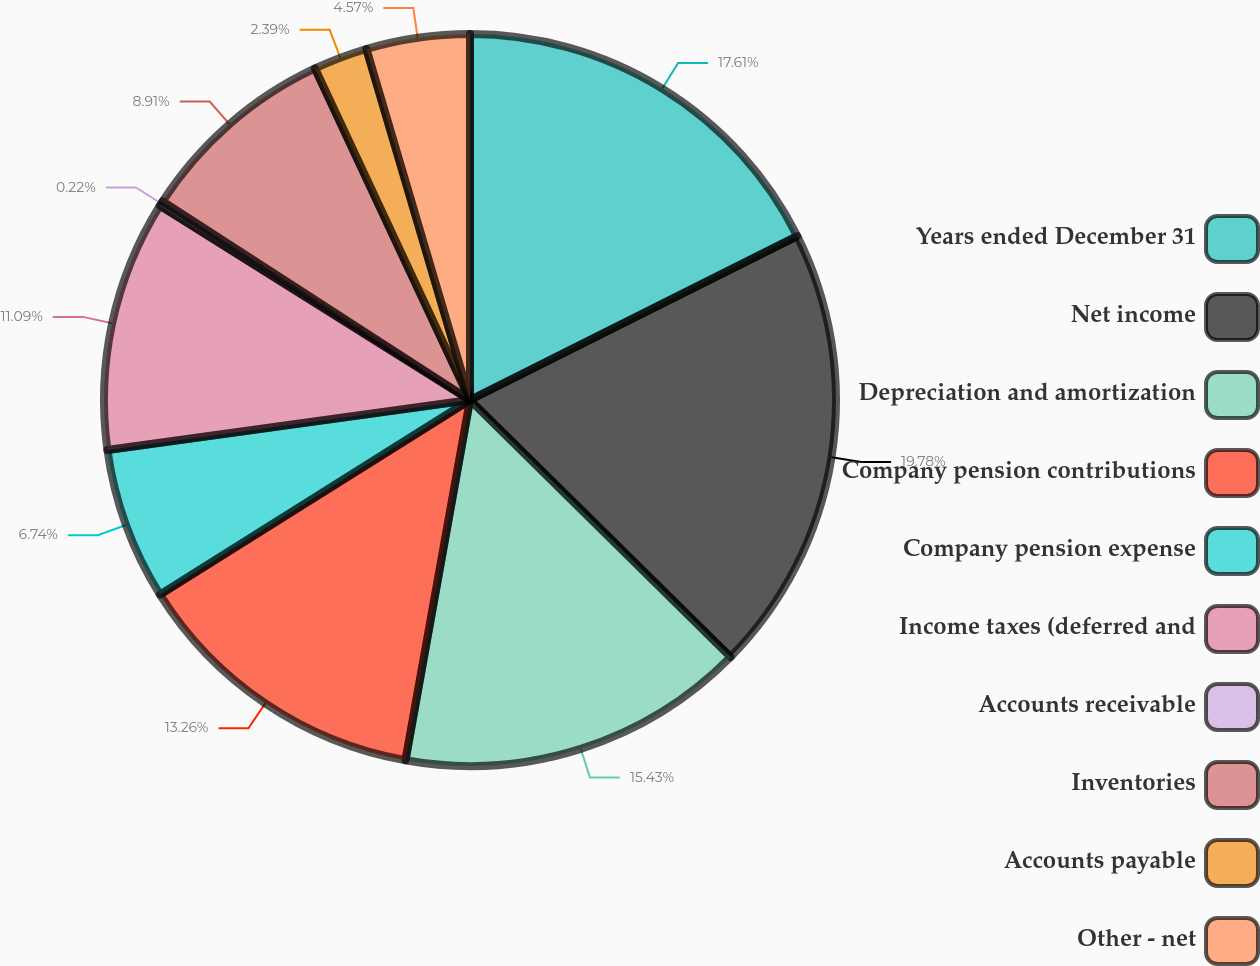Convert chart to OTSL. <chart><loc_0><loc_0><loc_500><loc_500><pie_chart><fcel>Years ended December 31<fcel>Net income<fcel>Depreciation and amortization<fcel>Company pension contributions<fcel>Company pension expense<fcel>Income taxes (deferred and<fcel>Accounts receivable<fcel>Inventories<fcel>Accounts payable<fcel>Other - net<nl><fcel>17.61%<fcel>19.78%<fcel>15.43%<fcel>13.26%<fcel>6.74%<fcel>11.09%<fcel>0.22%<fcel>8.91%<fcel>2.39%<fcel>4.57%<nl></chart> 